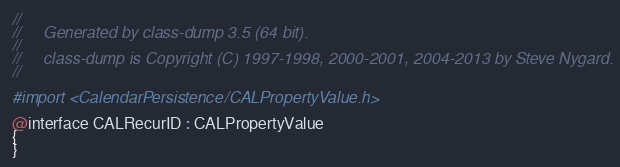Convert code to text. <code><loc_0><loc_0><loc_500><loc_500><_C_>//
//     Generated by class-dump 3.5 (64 bit).
//
//     class-dump is Copyright (C) 1997-1998, 2000-2001, 2004-2013 by Steve Nygard.
//

#import <CalendarPersistence/CALPropertyValue.h>

@interface CALRecurID : CALPropertyValue
{
}
</code> 